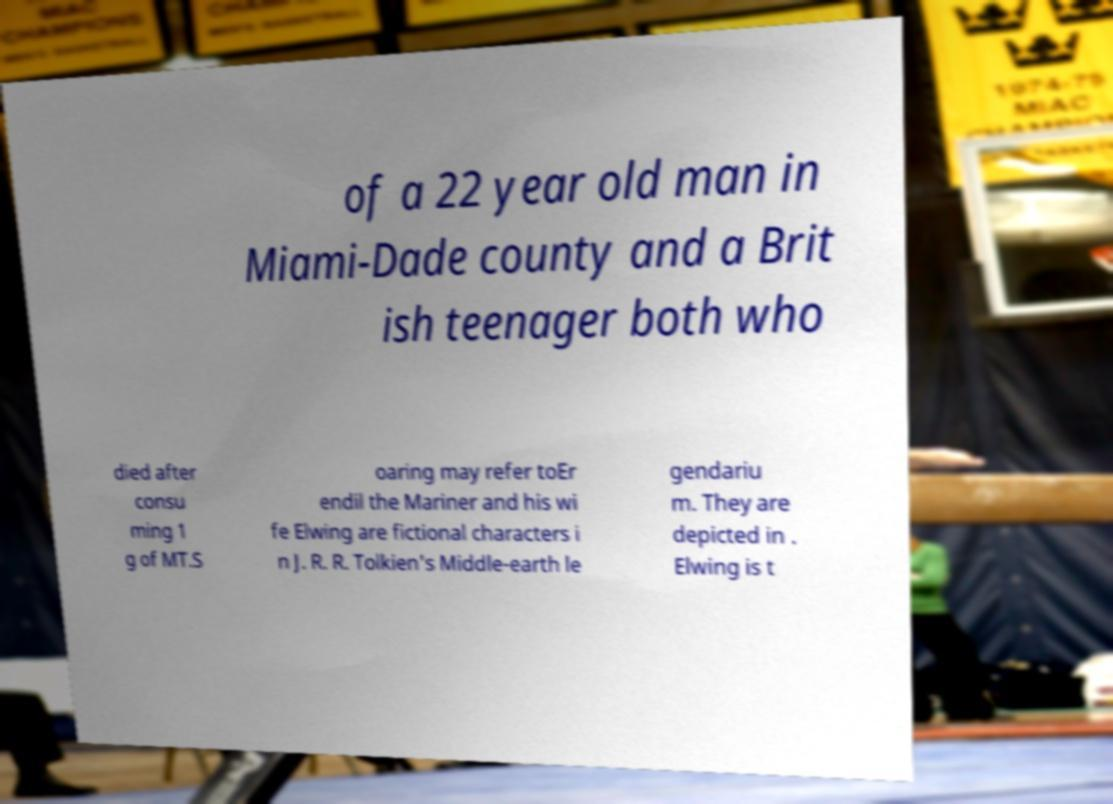Could you extract and type out the text from this image? of a 22 year old man in Miami-Dade county and a Brit ish teenager both who died after consu ming 1 g of MT.S oaring may refer toEr endil the Mariner and his wi fe Elwing are fictional characters i n J. R. R. Tolkien's Middle-earth le gendariu m. They are depicted in . Elwing is t 